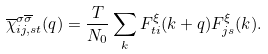Convert formula to latex. <formula><loc_0><loc_0><loc_500><loc_500>\overline { \chi } ^ { \sigma \overline { \sigma } } _ { i j , s t } ( q ) = \frac { T } { N _ { 0 } } \sum _ { k } F ^ { \xi } _ { t i } ( k + q ) F ^ { \xi } _ { j s } ( k ) .</formula> 